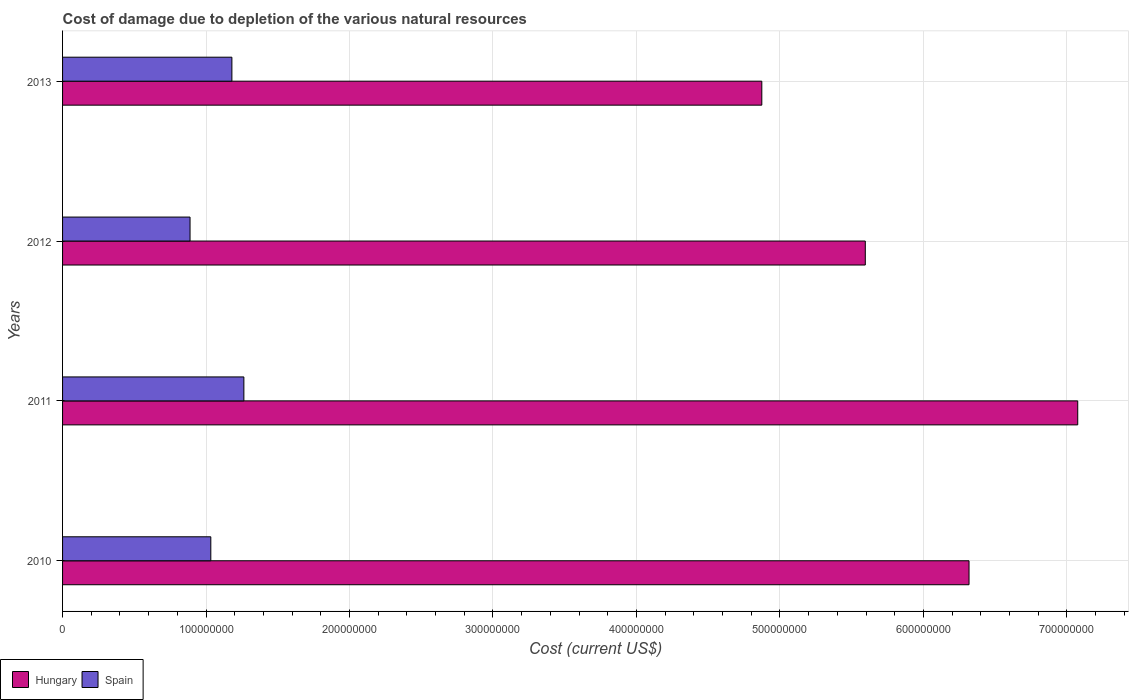How many different coloured bars are there?
Keep it short and to the point. 2. How many groups of bars are there?
Keep it short and to the point. 4. Are the number of bars on each tick of the Y-axis equal?
Provide a succinct answer. Yes. How many bars are there on the 3rd tick from the bottom?
Your answer should be compact. 2. What is the label of the 1st group of bars from the top?
Your answer should be compact. 2013. What is the cost of damage caused due to the depletion of various natural resources in Hungary in 2012?
Make the answer very short. 5.60e+08. Across all years, what is the maximum cost of damage caused due to the depletion of various natural resources in Hungary?
Ensure brevity in your answer.  7.08e+08. Across all years, what is the minimum cost of damage caused due to the depletion of various natural resources in Spain?
Provide a short and direct response. 8.89e+07. In which year was the cost of damage caused due to the depletion of various natural resources in Spain maximum?
Ensure brevity in your answer.  2011. What is the total cost of damage caused due to the depletion of various natural resources in Hungary in the graph?
Ensure brevity in your answer.  2.39e+09. What is the difference between the cost of damage caused due to the depletion of various natural resources in Hungary in 2011 and that in 2012?
Keep it short and to the point. 1.48e+08. What is the difference between the cost of damage caused due to the depletion of various natural resources in Spain in 2013 and the cost of damage caused due to the depletion of various natural resources in Hungary in 2012?
Your answer should be very brief. -4.41e+08. What is the average cost of damage caused due to the depletion of various natural resources in Hungary per year?
Your answer should be compact. 5.97e+08. In the year 2013, what is the difference between the cost of damage caused due to the depletion of various natural resources in Hungary and cost of damage caused due to the depletion of various natural resources in Spain?
Offer a terse response. 3.69e+08. What is the ratio of the cost of damage caused due to the depletion of various natural resources in Hungary in 2011 to that in 2013?
Offer a very short reply. 1.45. Is the cost of damage caused due to the depletion of various natural resources in Spain in 2010 less than that in 2011?
Make the answer very short. Yes. Is the difference between the cost of damage caused due to the depletion of various natural resources in Hungary in 2010 and 2012 greater than the difference between the cost of damage caused due to the depletion of various natural resources in Spain in 2010 and 2012?
Your answer should be very brief. Yes. What is the difference between the highest and the second highest cost of damage caused due to the depletion of various natural resources in Hungary?
Provide a succinct answer. 7.58e+07. What is the difference between the highest and the lowest cost of damage caused due to the depletion of various natural resources in Spain?
Offer a very short reply. 3.75e+07. In how many years, is the cost of damage caused due to the depletion of various natural resources in Spain greater than the average cost of damage caused due to the depletion of various natural resources in Spain taken over all years?
Your answer should be compact. 2. What does the 2nd bar from the top in 2010 represents?
Ensure brevity in your answer.  Hungary. What does the 1st bar from the bottom in 2011 represents?
Provide a short and direct response. Hungary. Are all the bars in the graph horizontal?
Ensure brevity in your answer.  Yes. Are the values on the major ticks of X-axis written in scientific E-notation?
Your answer should be very brief. No. Does the graph contain grids?
Offer a terse response. Yes. Where does the legend appear in the graph?
Ensure brevity in your answer.  Bottom left. How are the legend labels stacked?
Give a very brief answer. Horizontal. What is the title of the graph?
Provide a short and direct response. Cost of damage due to depletion of the various natural resources. Does "Suriname" appear as one of the legend labels in the graph?
Provide a short and direct response. No. What is the label or title of the X-axis?
Offer a terse response. Cost (current US$). What is the Cost (current US$) of Hungary in 2010?
Your answer should be compact. 6.32e+08. What is the Cost (current US$) in Spain in 2010?
Provide a succinct answer. 1.03e+08. What is the Cost (current US$) of Hungary in 2011?
Keep it short and to the point. 7.08e+08. What is the Cost (current US$) in Spain in 2011?
Keep it short and to the point. 1.26e+08. What is the Cost (current US$) in Hungary in 2012?
Your answer should be very brief. 5.60e+08. What is the Cost (current US$) of Spain in 2012?
Provide a succinct answer. 8.89e+07. What is the Cost (current US$) of Hungary in 2013?
Your answer should be compact. 4.87e+08. What is the Cost (current US$) in Spain in 2013?
Make the answer very short. 1.18e+08. Across all years, what is the maximum Cost (current US$) in Hungary?
Your answer should be compact. 7.08e+08. Across all years, what is the maximum Cost (current US$) of Spain?
Make the answer very short. 1.26e+08. Across all years, what is the minimum Cost (current US$) of Hungary?
Offer a very short reply. 4.87e+08. Across all years, what is the minimum Cost (current US$) in Spain?
Your answer should be compact. 8.89e+07. What is the total Cost (current US$) of Hungary in the graph?
Offer a terse response. 2.39e+09. What is the total Cost (current US$) of Spain in the graph?
Offer a terse response. 4.37e+08. What is the difference between the Cost (current US$) of Hungary in 2010 and that in 2011?
Offer a very short reply. -7.58e+07. What is the difference between the Cost (current US$) in Spain in 2010 and that in 2011?
Offer a very short reply. -2.30e+07. What is the difference between the Cost (current US$) of Hungary in 2010 and that in 2012?
Your answer should be very brief. 7.23e+07. What is the difference between the Cost (current US$) of Spain in 2010 and that in 2012?
Keep it short and to the point. 1.45e+07. What is the difference between the Cost (current US$) in Hungary in 2010 and that in 2013?
Provide a succinct answer. 1.44e+08. What is the difference between the Cost (current US$) of Spain in 2010 and that in 2013?
Your answer should be compact. -1.47e+07. What is the difference between the Cost (current US$) in Hungary in 2011 and that in 2012?
Keep it short and to the point. 1.48e+08. What is the difference between the Cost (current US$) of Spain in 2011 and that in 2012?
Give a very brief answer. 3.75e+07. What is the difference between the Cost (current US$) of Hungary in 2011 and that in 2013?
Provide a succinct answer. 2.20e+08. What is the difference between the Cost (current US$) in Spain in 2011 and that in 2013?
Ensure brevity in your answer.  8.35e+06. What is the difference between the Cost (current US$) in Hungary in 2012 and that in 2013?
Make the answer very short. 7.21e+07. What is the difference between the Cost (current US$) of Spain in 2012 and that in 2013?
Your response must be concise. -2.92e+07. What is the difference between the Cost (current US$) in Hungary in 2010 and the Cost (current US$) in Spain in 2011?
Your answer should be very brief. 5.05e+08. What is the difference between the Cost (current US$) of Hungary in 2010 and the Cost (current US$) of Spain in 2012?
Make the answer very short. 5.43e+08. What is the difference between the Cost (current US$) in Hungary in 2010 and the Cost (current US$) in Spain in 2013?
Your response must be concise. 5.14e+08. What is the difference between the Cost (current US$) in Hungary in 2011 and the Cost (current US$) in Spain in 2012?
Keep it short and to the point. 6.19e+08. What is the difference between the Cost (current US$) in Hungary in 2011 and the Cost (current US$) in Spain in 2013?
Your answer should be very brief. 5.90e+08. What is the difference between the Cost (current US$) of Hungary in 2012 and the Cost (current US$) of Spain in 2013?
Provide a succinct answer. 4.41e+08. What is the average Cost (current US$) in Hungary per year?
Provide a succinct answer. 5.97e+08. What is the average Cost (current US$) of Spain per year?
Provide a short and direct response. 1.09e+08. In the year 2010, what is the difference between the Cost (current US$) in Hungary and Cost (current US$) in Spain?
Make the answer very short. 5.28e+08. In the year 2011, what is the difference between the Cost (current US$) in Hungary and Cost (current US$) in Spain?
Offer a very short reply. 5.81e+08. In the year 2012, what is the difference between the Cost (current US$) of Hungary and Cost (current US$) of Spain?
Provide a succinct answer. 4.71e+08. In the year 2013, what is the difference between the Cost (current US$) of Hungary and Cost (current US$) of Spain?
Offer a very short reply. 3.69e+08. What is the ratio of the Cost (current US$) in Hungary in 2010 to that in 2011?
Your answer should be compact. 0.89. What is the ratio of the Cost (current US$) in Spain in 2010 to that in 2011?
Give a very brief answer. 0.82. What is the ratio of the Cost (current US$) of Hungary in 2010 to that in 2012?
Provide a short and direct response. 1.13. What is the ratio of the Cost (current US$) in Spain in 2010 to that in 2012?
Your answer should be compact. 1.16. What is the ratio of the Cost (current US$) of Hungary in 2010 to that in 2013?
Offer a very short reply. 1.3. What is the ratio of the Cost (current US$) of Spain in 2010 to that in 2013?
Your response must be concise. 0.88. What is the ratio of the Cost (current US$) in Hungary in 2011 to that in 2012?
Provide a short and direct response. 1.26. What is the ratio of the Cost (current US$) of Spain in 2011 to that in 2012?
Provide a short and direct response. 1.42. What is the ratio of the Cost (current US$) of Hungary in 2011 to that in 2013?
Your answer should be compact. 1.45. What is the ratio of the Cost (current US$) of Spain in 2011 to that in 2013?
Provide a succinct answer. 1.07. What is the ratio of the Cost (current US$) of Hungary in 2012 to that in 2013?
Keep it short and to the point. 1.15. What is the ratio of the Cost (current US$) of Spain in 2012 to that in 2013?
Your answer should be very brief. 0.75. What is the difference between the highest and the second highest Cost (current US$) in Hungary?
Offer a very short reply. 7.58e+07. What is the difference between the highest and the second highest Cost (current US$) of Spain?
Give a very brief answer. 8.35e+06. What is the difference between the highest and the lowest Cost (current US$) in Hungary?
Your response must be concise. 2.20e+08. What is the difference between the highest and the lowest Cost (current US$) of Spain?
Provide a succinct answer. 3.75e+07. 